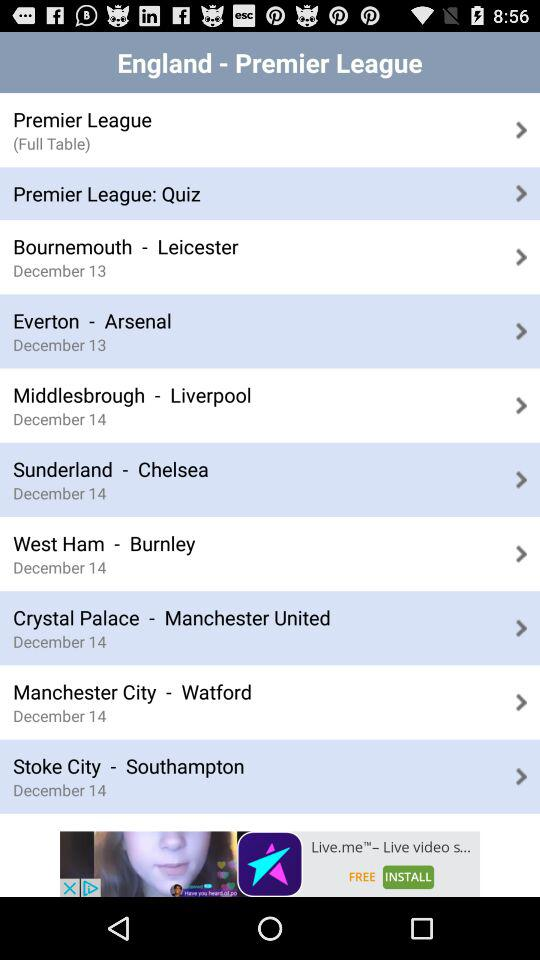How many more days until the last match?
Answer the question using a single word or phrase. 1 